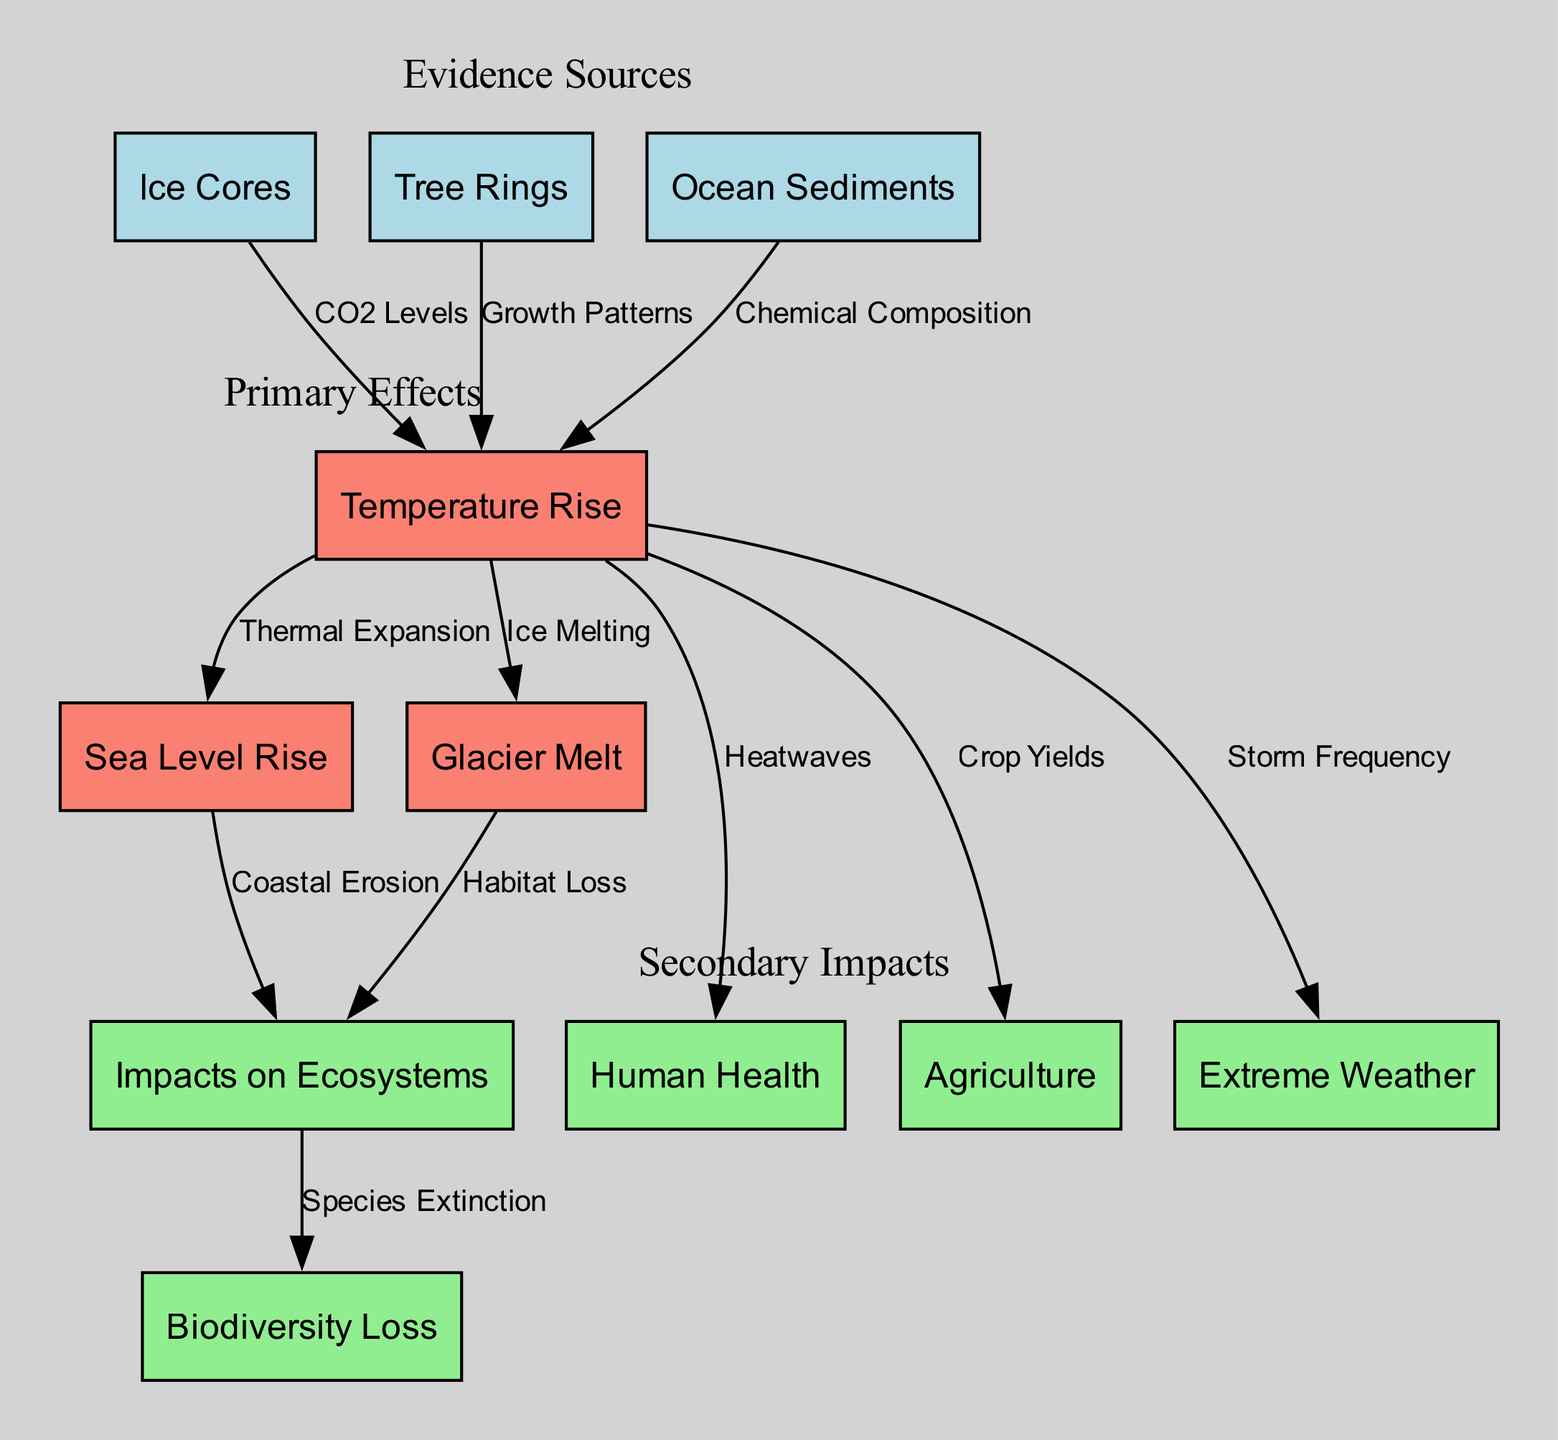What are the evidence sources in the diagram? The nodes labeled as 'Ice Cores', 'Tree Rings', and 'Ocean Sediments' collectively represent the sources of evidence that highlight climate change.
Answer: Ice Cores, Tree Rings, Ocean Sediments How many primary effects are indicated in the diagram? The primary effects are grouped under the node category that includes 'Temperature Rise', 'Sea Level Rise', and 'Glacier Melt'. Counting these nodes results in a total of three primary effects.
Answer: 3 What connects ice cores to temperature rise? The relationship is indicated by an edge labeled 'CO2 Levels', which shows that ice cores provide data related to carbon dioxide levels that contribute to temperature rise.
Answer: CO2 Levels What is the impact of sea level rise on ecosystems? The diagram shows an edge leading from 'Sea Level Rise' to 'Impacts on Ecosystems' labeled 'Coastal Erosion', indicating this specific impact of sea level rise.
Answer: Coastal Erosion Which impacts are linked to temperature rise? Multiple edges connect 'Temperature Rise' to other nodes, specifically 'Sea Level Rise', 'Glacier Melt', 'Human Health', 'Agriculture', and 'Extreme Weather', indicating diverse impacts of temperature rise.
Answer: Sea Level Rise, Glacier Melt, Human Health, Agriculture, Extreme Weather How does glacier melt affect biodiversity loss? An edge leads from 'Glacier Melt' to 'Impacts on Ecosystems', and another edge connects 'Impacts on Ecosystems' to 'Biodiversity Loss' labeled 'Species Extinction', indicating a pathway from glacier melt to biodiversity loss through impacts on ecosystems.
Answer: Habitat Loss, Species Extinction What evidence source suggests ancient climate conditions? The node labeled 'Ice Cores' represents evidence sources of ancient climate conditions by preserving gas bubbles from past atmospheres, informing about historical climate changes.
Answer: Ice Cores What specific health impact is related to temperature rise? The edge connecting 'Temperature Rise' to 'Human Health' is labeled 'Heatwaves', which specifically identifies this health impact associated with rising temperatures.
Answer: Heatwaves 